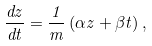<formula> <loc_0><loc_0><loc_500><loc_500>\frac { d z } { d t } = \frac { 1 } { m } \left ( \alpha z + \beta t \right ) ,</formula> 